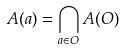Convert formula to latex. <formula><loc_0><loc_0><loc_500><loc_500>A ( a ) = \bigcap _ { a \in O } A ( O )</formula> 